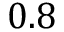<formula> <loc_0><loc_0><loc_500><loc_500>0 . 8</formula> 